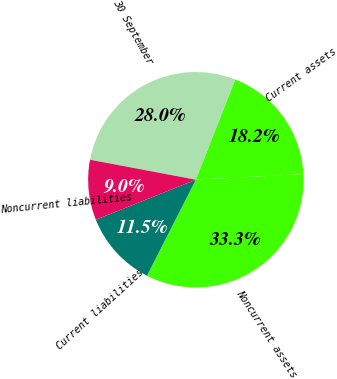Convert chart to OTSL. <chart><loc_0><loc_0><loc_500><loc_500><pie_chart><fcel>30 September<fcel>Current assets<fcel>Noncurrent assets<fcel>Current liabilities<fcel>Noncurrent liabilities<nl><fcel>28.0%<fcel>18.19%<fcel>33.33%<fcel>11.45%<fcel>9.02%<nl></chart> 